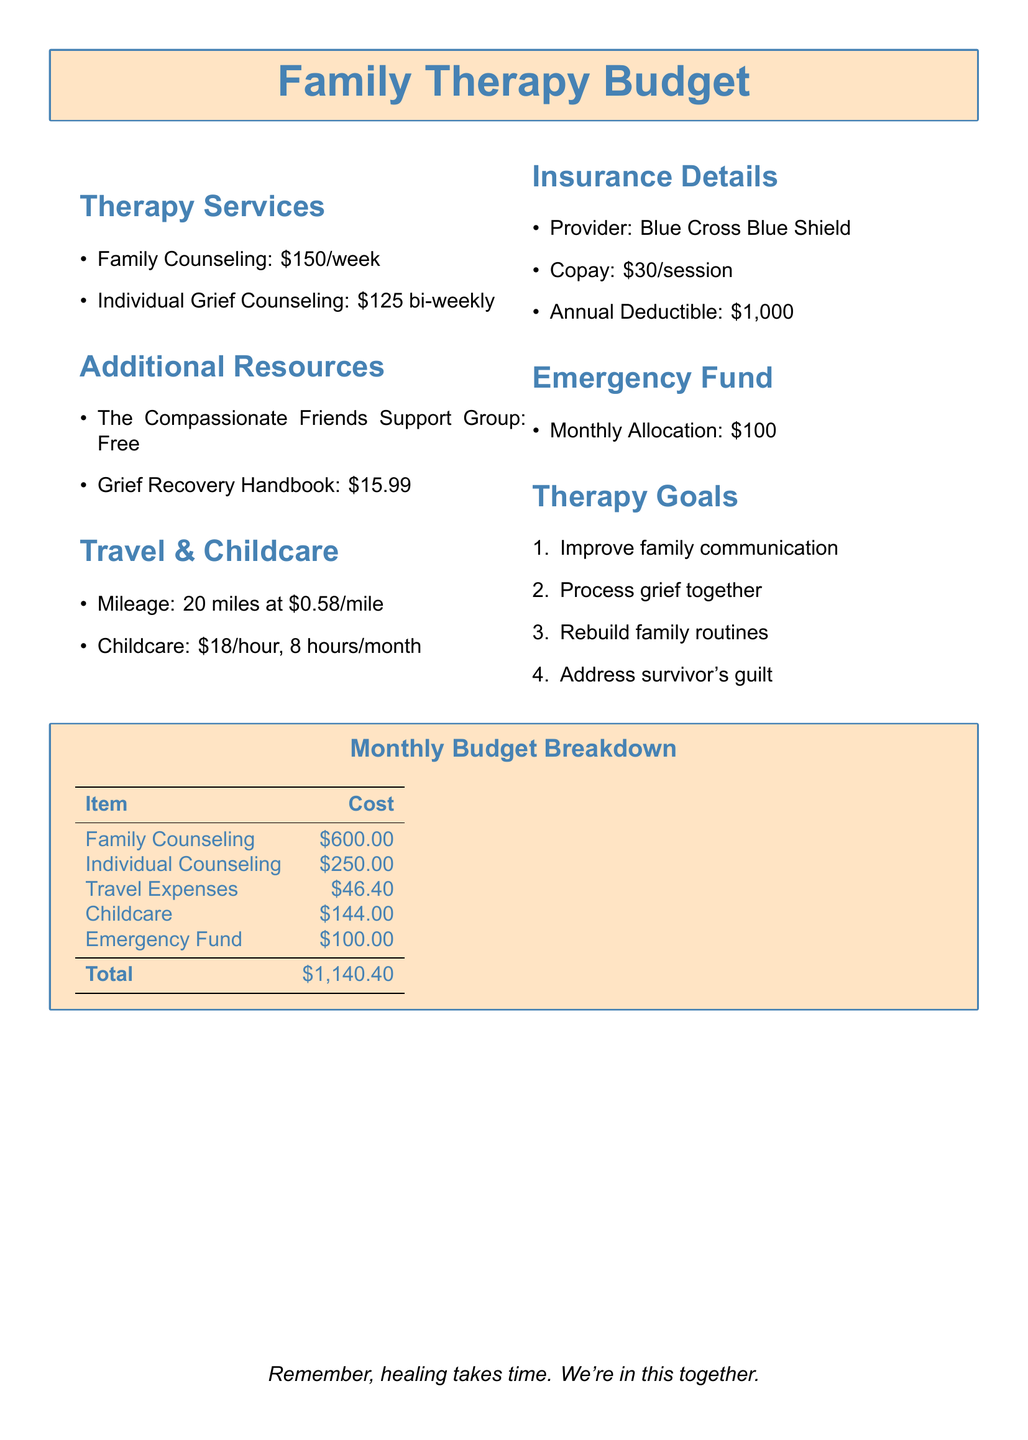What is the cost of family counseling? The document states that family counseling costs $150 per week.
Answer: $150/week What is the total monthly cost for family counseling? The document indicates that family counseling costs $600 per month.
Answer: $600.00 How much is the copay per session? The document specifies that the copay per session is $30.
Answer: $30 What is the expected monthly allocation for the emergency fund? The document mentions a monthly allocation of $100 for the emergency fund.
Answer: $100 How much does childcare cost per hour? The document indicates that childcare costs $18 per hour.
Answer: $18/hour What are the goals of the therapy? The document lists four goals for the therapy.
Answer: Improve family communication, Process grief together, Rebuild family routines, Address survivor's guilt What is the total amount for travel expenses? The document provides the cost of travel expenses as $46.40.
Answer: $46.40 How often is individual grief counseling scheduled? The document states that individual grief counseling is bi-weekly.
Answer: Bi-weekly What is the total budget for therapy sessions and related expenses? The document indicates that the total cost is $1,140.40.
Answer: $1,140.40 